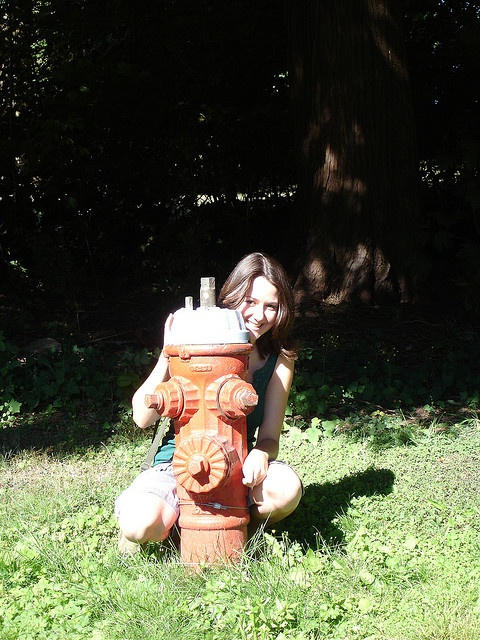Describe the objects in this image and their specific colors. I can see fire hydrant in black, ivory, tan, and salmon tones and people in black, white, and gray tones in this image. 